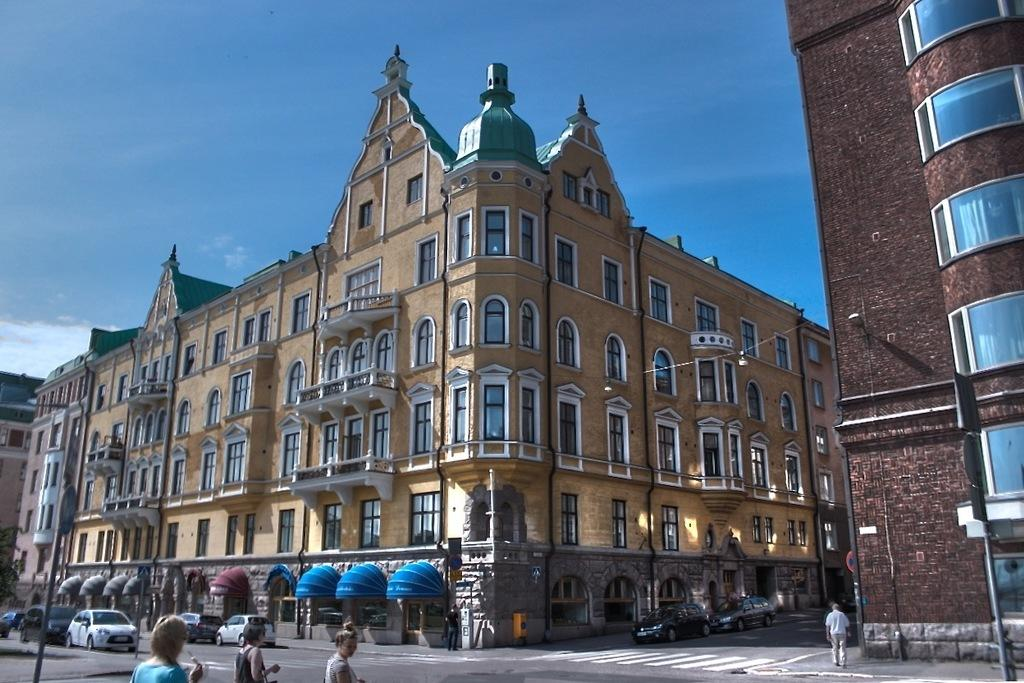What types of subjects can be seen in the image? There are persons and vehicles in the image. Where are the persons and vehicles located in the image? The vehicles and persons are at the bottom of the image. What else can be seen in the middle of the image besides the persons and vehicles? There are buildings in the middle of the image. What is visible at the top of the image? The sky is visible at the top of the image. What type of cap is being worn by the person in the image? There is no cap visible in the image; the persons are not wearing any headgear. What kind of attraction can be seen in the image? There is no attraction present in the image; it features persons, vehicles, buildings, and the sky. 